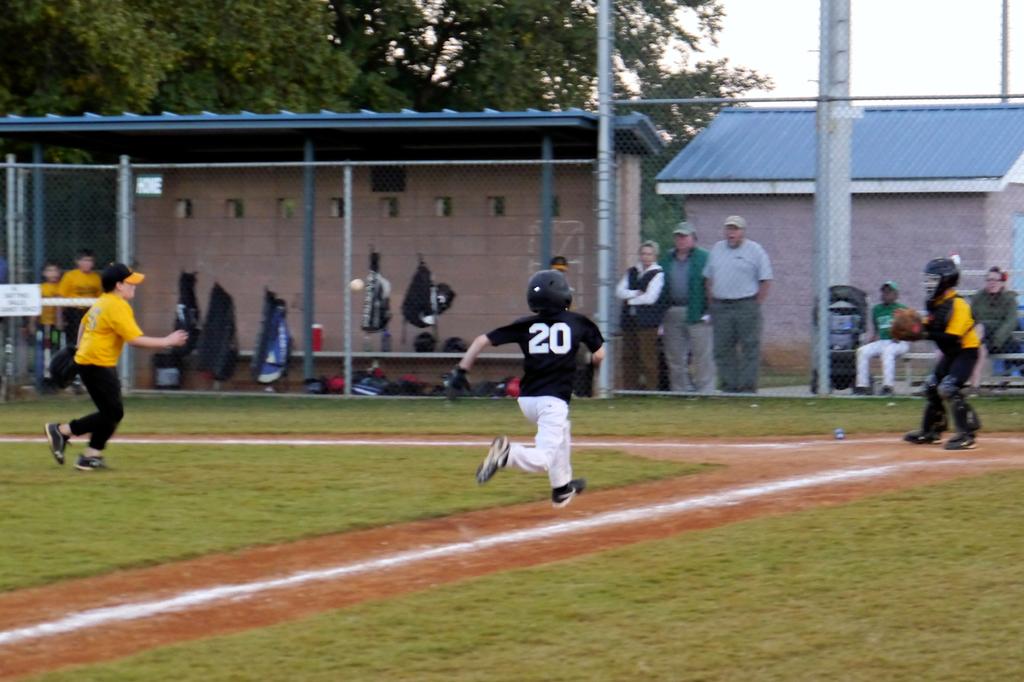What is the player's number?
Make the answer very short. 20. 